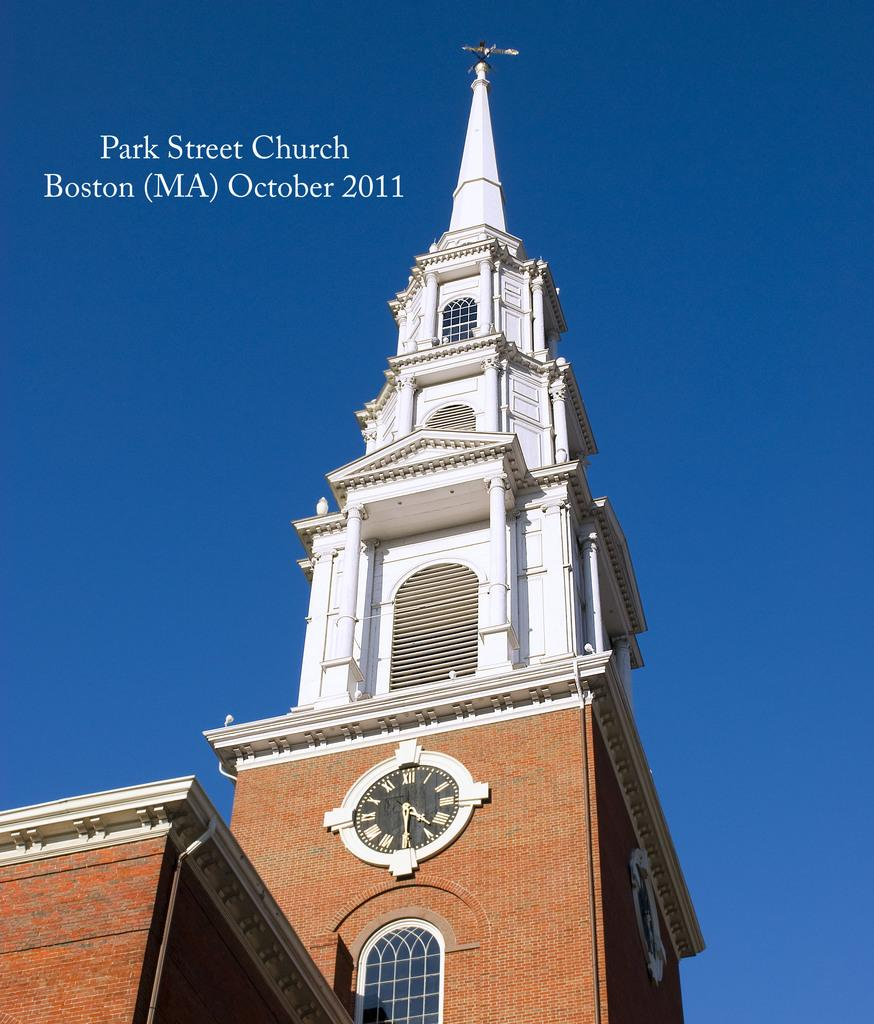<image>
Describe the image concisely. A Tower of Park Street Church against a blue sky. 